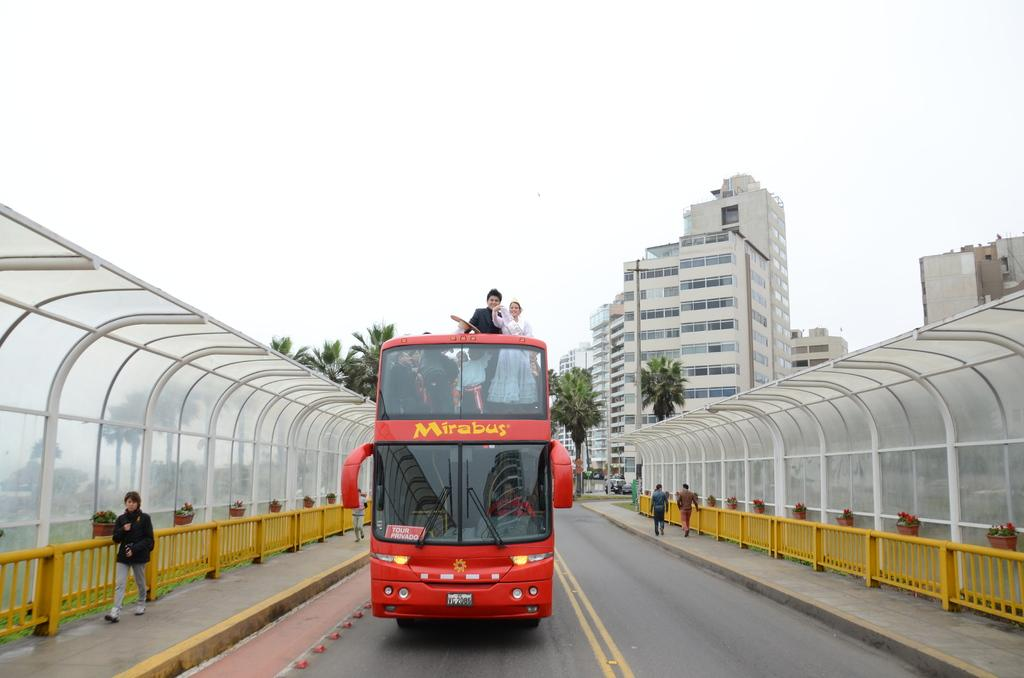Provide a one-sentence caption for the provided image. A red double decker bus with a yellow Mirabus logo on the front. 